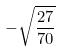<formula> <loc_0><loc_0><loc_500><loc_500>- \sqrt { \frac { 2 7 } { 7 0 } }</formula> 